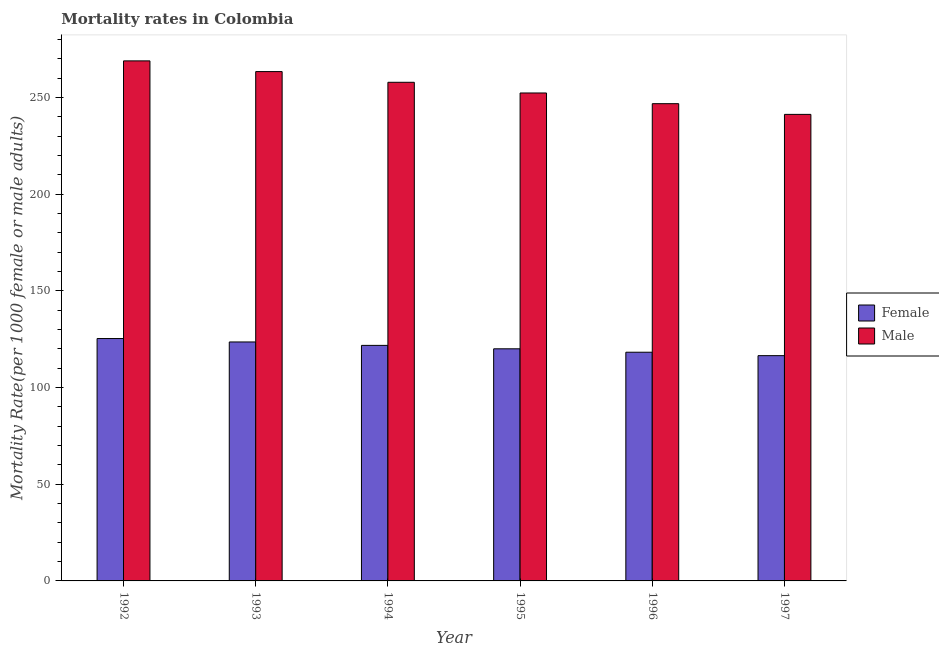How many different coloured bars are there?
Offer a terse response. 2. How many groups of bars are there?
Offer a terse response. 6. How many bars are there on the 2nd tick from the left?
Your response must be concise. 2. How many bars are there on the 6th tick from the right?
Provide a short and direct response. 2. What is the male mortality rate in 1993?
Keep it short and to the point. 263.33. Across all years, what is the maximum female mortality rate?
Your answer should be very brief. 125.31. Across all years, what is the minimum female mortality rate?
Your response must be concise. 116.47. In which year was the male mortality rate maximum?
Your answer should be very brief. 1992. In which year was the female mortality rate minimum?
Your response must be concise. 1997. What is the total female mortality rate in the graph?
Give a very brief answer. 725.33. What is the difference between the male mortality rate in 1992 and that in 1997?
Make the answer very short. 27.66. What is the difference between the female mortality rate in 1992 and the male mortality rate in 1996?
Provide a short and direct response. 7.08. What is the average female mortality rate per year?
Ensure brevity in your answer.  120.89. In the year 1992, what is the difference between the female mortality rate and male mortality rate?
Your answer should be compact. 0. In how many years, is the male mortality rate greater than 110?
Ensure brevity in your answer.  6. What is the ratio of the female mortality rate in 1993 to that in 1994?
Ensure brevity in your answer.  1.01. Is the male mortality rate in 1992 less than that in 1993?
Ensure brevity in your answer.  No. Is the difference between the male mortality rate in 1994 and 1996 greater than the difference between the female mortality rate in 1994 and 1996?
Keep it short and to the point. No. What is the difference between the highest and the second highest male mortality rate?
Make the answer very short. 5.53. What is the difference between the highest and the lowest female mortality rate?
Keep it short and to the point. 8.84. In how many years, is the male mortality rate greater than the average male mortality rate taken over all years?
Make the answer very short. 3. Is the sum of the female mortality rate in 1993 and 1996 greater than the maximum male mortality rate across all years?
Offer a terse response. Yes. What does the 1st bar from the left in 1992 represents?
Make the answer very short. Female. What does the 1st bar from the right in 1995 represents?
Ensure brevity in your answer.  Male. How many bars are there?
Your answer should be compact. 12. How many years are there in the graph?
Your answer should be compact. 6. Are the values on the major ticks of Y-axis written in scientific E-notation?
Keep it short and to the point. No. Where does the legend appear in the graph?
Ensure brevity in your answer.  Center right. How many legend labels are there?
Make the answer very short. 2. How are the legend labels stacked?
Keep it short and to the point. Vertical. What is the title of the graph?
Your answer should be compact. Mortality rates in Colombia. What is the label or title of the X-axis?
Offer a terse response. Year. What is the label or title of the Y-axis?
Provide a short and direct response. Mortality Rate(per 1000 female or male adults). What is the Mortality Rate(per 1000 female or male adults) of Female in 1992?
Offer a very short reply. 125.31. What is the Mortality Rate(per 1000 female or male adults) in Male in 1992?
Offer a very short reply. 268.86. What is the Mortality Rate(per 1000 female or male adults) of Female in 1993?
Offer a very short reply. 123.54. What is the Mortality Rate(per 1000 female or male adults) of Male in 1993?
Your response must be concise. 263.33. What is the Mortality Rate(per 1000 female or male adults) in Female in 1994?
Keep it short and to the point. 121.77. What is the Mortality Rate(per 1000 female or male adults) of Male in 1994?
Your response must be concise. 257.79. What is the Mortality Rate(per 1000 female or male adults) of Female in 1995?
Your answer should be very brief. 120. What is the Mortality Rate(per 1000 female or male adults) of Male in 1995?
Provide a short and direct response. 252.26. What is the Mortality Rate(per 1000 female or male adults) in Female in 1996?
Provide a short and direct response. 118.23. What is the Mortality Rate(per 1000 female or male adults) of Male in 1996?
Your response must be concise. 246.73. What is the Mortality Rate(per 1000 female or male adults) in Female in 1997?
Offer a very short reply. 116.47. What is the Mortality Rate(per 1000 female or male adults) in Male in 1997?
Keep it short and to the point. 241.19. Across all years, what is the maximum Mortality Rate(per 1000 female or male adults) in Female?
Your response must be concise. 125.31. Across all years, what is the maximum Mortality Rate(per 1000 female or male adults) in Male?
Ensure brevity in your answer.  268.86. Across all years, what is the minimum Mortality Rate(per 1000 female or male adults) of Female?
Provide a succinct answer. 116.47. Across all years, what is the minimum Mortality Rate(per 1000 female or male adults) of Male?
Your answer should be very brief. 241.19. What is the total Mortality Rate(per 1000 female or male adults) of Female in the graph?
Give a very brief answer. 725.33. What is the total Mortality Rate(per 1000 female or male adults) in Male in the graph?
Your answer should be compact. 1530.16. What is the difference between the Mortality Rate(per 1000 female or male adults) of Female in 1992 and that in 1993?
Offer a terse response. 1.77. What is the difference between the Mortality Rate(per 1000 female or male adults) in Male in 1992 and that in 1993?
Your answer should be very brief. 5.53. What is the difference between the Mortality Rate(per 1000 female or male adults) in Female in 1992 and that in 1994?
Ensure brevity in your answer.  3.54. What is the difference between the Mortality Rate(per 1000 female or male adults) in Male in 1992 and that in 1994?
Give a very brief answer. 11.07. What is the difference between the Mortality Rate(per 1000 female or male adults) in Female in 1992 and that in 1995?
Your answer should be very brief. 5.31. What is the difference between the Mortality Rate(per 1000 female or male adults) of Male in 1992 and that in 1995?
Keep it short and to the point. 16.6. What is the difference between the Mortality Rate(per 1000 female or male adults) of Female in 1992 and that in 1996?
Offer a terse response. 7.08. What is the difference between the Mortality Rate(per 1000 female or male adults) in Male in 1992 and that in 1996?
Give a very brief answer. 22.13. What is the difference between the Mortality Rate(per 1000 female or male adults) of Female in 1992 and that in 1997?
Provide a succinct answer. 8.85. What is the difference between the Mortality Rate(per 1000 female or male adults) in Male in 1992 and that in 1997?
Your answer should be very brief. 27.66. What is the difference between the Mortality Rate(per 1000 female or male adults) of Female in 1993 and that in 1994?
Your answer should be compact. 1.77. What is the difference between the Mortality Rate(per 1000 female or male adults) in Male in 1993 and that in 1994?
Your response must be concise. 5.53. What is the difference between the Mortality Rate(per 1000 female or male adults) of Female in 1993 and that in 1995?
Your response must be concise. 3.54. What is the difference between the Mortality Rate(per 1000 female or male adults) of Male in 1993 and that in 1995?
Give a very brief answer. 11.06. What is the difference between the Mortality Rate(per 1000 female or male adults) in Female in 1993 and that in 1996?
Your answer should be very brief. 5.31. What is the difference between the Mortality Rate(per 1000 female or male adults) of Male in 1993 and that in 1996?
Give a very brief answer. 16.6. What is the difference between the Mortality Rate(per 1000 female or male adults) of Female in 1993 and that in 1997?
Give a very brief answer. 7.08. What is the difference between the Mortality Rate(per 1000 female or male adults) in Male in 1993 and that in 1997?
Provide a short and direct response. 22.13. What is the difference between the Mortality Rate(per 1000 female or male adults) in Female in 1994 and that in 1995?
Ensure brevity in your answer.  1.77. What is the difference between the Mortality Rate(per 1000 female or male adults) of Male in 1994 and that in 1995?
Your answer should be very brief. 5.53. What is the difference between the Mortality Rate(per 1000 female or male adults) of Female in 1994 and that in 1996?
Make the answer very short. 3.54. What is the difference between the Mortality Rate(per 1000 female or male adults) of Male in 1994 and that in 1996?
Your response must be concise. 11.06. What is the difference between the Mortality Rate(per 1000 female or male adults) of Female in 1994 and that in 1997?
Your answer should be very brief. 5.31. What is the difference between the Mortality Rate(per 1000 female or male adults) of Male in 1994 and that in 1997?
Ensure brevity in your answer.  16.6. What is the difference between the Mortality Rate(per 1000 female or male adults) in Female in 1995 and that in 1996?
Provide a short and direct response. 1.77. What is the difference between the Mortality Rate(per 1000 female or male adults) in Male in 1995 and that in 1996?
Offer a terse response. 5.53. What is the difference between the Mortality Rate(per 1000 female or male adults) of Female in 1995 and that in 1997?
Your response must be concise. 3.54. What is the difference between the Mortality Rate(per 1000 female or male adults) in Male in 1995 and that in 1997?
Keep it short and to the point. 11.07. What is the difference between the Mortality Rate(per 1000 female or male adults) of Female in 1996 and that in 1997?
Your response must be concise. 1.77. What is the difference between the Mortality Rate(per 1000 female or male adults) in Male in 1996 and that in 1997?
Provide a short and direct response. 5.53. What is the difference between the Mortality Rate(per 1000 female or male adults) of Female in 1992 and the Mortality Rate(per 1000 female or male adults) of Male in 1993?
Ensure brevity in your answer.  -138.02. What is the difference between the Mortality Rate(per 1000 female or male adults) of Female in 1992 and the Mortality Rate(per 1000 female or male adults) of Male in 1994?
Keep it short and to the point. -132.48. What is the difference between the Mortality Rate(per 1000 female or male adults) in Female in 1992 and the Mortality Rate(per 1000 female or male adults) in Male in 1995?
Provide a short and direct response. -126.95. What is the difference between the Mortality Rate(per 1000 female or male adults) in Female in 1992 and the Mortality Rate(per 1000 female or male adults) in Male in 1996?
Make the answer very short. -121.42. What is the difference between the Mortality Rate(per 1000 female or male adults) of Female in 1992 and the Mortality Rate(per 1000 female or male adults) of Male in 1997?
Offer a very short reply. -115.89. What is the difference between the Mortality Rate(per 1000 female or male adults) of Female in 1993 and the Mortality Rate(per 1000 female or male adults) of Male in 1994?
Ensure brevity in your answer.  -134.25. What is the difference between the Mortality Rate(per 1000 female or male adults) of Female in 1993 and the Mortality Rate(per 1000 female or male adults) of Male in 1995?
Ensure brevity in your answer.  -128.72. What is the difference between the Mortality Rate(per 1000 female or male adults) in Female in 1993 and the Mortality Rate(per 1000 female or male adults) in Male in 1996?
Offer a terse response. -123.19. What is the difference between the Mortality Rate(per 1000 female or male adults) of Female in 1993 and the Mortality Rate(per 1000 female or male adults) of Male in 1997?
Ensure brevity in your answer.  -117.65. What is the difference between the Mortality Rate(per 1000 female or male adults) of Female in 1994 and the Mortality Rate(per 1000 female or male adults) of Male in 1995?
Your answer should be compact. -130.49. What is the difference between the Mortality Rate(per 1000 female or male adults) in Female in 1994 and the Mortality Rate(per 1000 female or male adults) in Male in 1996?
Your answer should be compact. -124.96. What is the difference between the Mortality Rate(per 1000 female or male adults) in Female in 1994 and the Mortality Rate(per 1000 female or male adults) in Male in 1997?
Ensure brevity in your answer.  -119.42. What is the difference between the Mortality Rate(per 1000 female or male adults) of Female in 1995 and the Mortality Rate(per 1000 female or male adults) of Male in 1996?
Your answer should be very brief. -126.72. What is the difference between the Mortality Rate(per 1000 female or male adults) in Female in 1995 and the Mortality Rate(per 1000 female or male adults) in Male in 1997?
Your answer should be compact. -121.19. What is the difference between the Mortality Rate(per 1000 female or male adults) in Female in 1996 and the Mortality Rate(per 1000 female or male adults) in Male in 1997?
Give a very brief answer. -122.96. What is the average Mortality Rate(per 1000 female or male adults) of Female per year?
Your answer should be very brief. 120.89. What is the average Mortality Rate(per 1000 female or male adults) in Male per year?
Ensure brevity in your answer.  255.03. In the year 1992, what is the difference between the Mortality Rate(per 1000 female or male adults) of Female and Mortality Rate(per 1000 female or male adults) of Male?
Offer a terse response. -143.55. In the year 1993, what is the difference between the Mortality Rate(per 1000 female or male adults) in Female and Mortality Rate(per 1000 female or male adults) in Male?
Your answer should be compact. -139.78. In the year 1994, what is the difference between the Mortality Rate(per 1000 female or male adults) in Female and Mortality Rate(per 1000 female or male adults) in Male?
Provide a succinct answer. -136.02. In the year 1995, what is the difference between the Mortality Rate(per 1000 female or male adults) in Female and Mortality Rate(per 1000 female or male adults) in Male?
Keep it short and to the point. -132.26. In the year 1996, what is the difference between the Mortality Rate(per 1000 female or male adults) in Female and Mortality Rate(per 1000 female or male adults) in Male?
Offer a very short reply. -128.49. In the year 1997, what is the difference between the Mortality Rate(per 1000 female or male adults) in Female and Mortality Rate(per 1000 female or male adults) in Male?
Provide a succinct answer. -124.73. What is the ratio of the Mortality Rate(per 1000 female or male adults) in Female in 1992 to that in 1993?
Offer a very short reply. 1.01. What is the ratio of the Mortality Rate(per 1000 female or male adults) of Female in 1992 to that in 1994?
Offer a very short reply. 1.03. What is the ratio of the Mortality Rate(per 1000 female or male adults) of Male in 1992 to that in 1994?
Make the answer very short. 1.04. What is the ratio of the Mortality Rate(per 1000 female or male adults) in Female in 1992 to that in 1995?
Make the answer very short. 1.04. What is the ratio of the Mortality Rate(per 1000 female or male adults) of Male in 1992 to that in 1995?
Your response must be concise. 1.07. What is the ratio of the Mortality Rate(per 1000 female or male adults) of Female in 1992 to that in 1996?
Your response must be concise. 1.06. What is the ratio of the Mortality Rate(per 1000 female or male adults) of Male in 1992 to that in 1996?
Ensure brevity in your answer.  1.09. What is the ratio of the Mortality Rate(per 1000 female or male adults) of Female in 1992 to that in 1997?
Make the answer very short. 1.08. What is the ratio of the Mortality Rate(per 1000 female or male adults) in Male in 1992 to that in 1997?
Your answer should be compact. 1.11. What is the ratio of the Mortality Rate(per 1000 female or male adults) in Female in 1993 to that in 1994?
Give a very brief answer. 1.01. What is the ratio of the Mortality Rate(per 1000 female or male adults) in Male in 1993 to that in 1994?
Give a very brief answer. 1.02. What is the ratio of the Mortality Rate(per 1000 female or male adults) in Female in 1993 to that in 1995?
Ensure brevity in your answer.  1.03. What is the ratio of the Mortality Rate(per 1000 female or male adults) in Male in 1993 to that in 1995?
Offer a very short reply. 1.04. What is the ratio of the Mortality Rate(per 1000 female or male adults) of Female in 1993 to that in 1996?
Offer a terse response. 1.04. What is the ratio of the Mortality Rate(per 1000 female or male adults) in Male in 1993 to that in 1996?
Provide a succinct answer. 1.07. What is the ratio of the Mortality Rate(per 1000 female or male adults) in Female in 1993 to that in 1997?
Keep it short and to the point. 1.06. What is the ratio of the Mortality Rate(per 1000 female or male adults) in Male in 1993 to that in 1997?
Provide a succinct answer. 1.09. What is the ratio of the Mortality Rate(per 1000 female or male adults) in Female in 1994 to that in 1995?
Ensure brevity in your answer.  1.01. What is the ratio of the Mortality Rate(per 1000 female or male adults) of Male in 1994 to that in 1995?
Provide a short and direct response. 1.02. What is the ratio of the Mortality Rate(per 1000 female or male adults) of Female in 1994 to that in 1996?
Give a very brief answer. 1.03. What is the ratio of the Mortality Rate(per 1000 female or male adults) of Male in 1994 to that in 1996?
Make the answer very short. 1.04. What is the ratio of the Mortality Rate(per 1000 female or male adults) of Female in 1994 to that in 1997?
Provide a succinct answer. 1.05. What is the ratio of the Mortality Rate(per 1000 female or male adults) in Male in 1994 to that in 1997?
Ensure brevity in your answer.  1.07. What is the ratio of the Mortality Rate(per 1000 female or male adults) in Female in 1995 to that in 1996?
Ensure brevity in your answer.  1.01. What is the ratio of the Mortality Rate(per 1000 female or male adults) in Male in 1995 to that in 1996?
Make the answer very short. 1.02. What is the ratio of the Mortality Rate(per 1000 female or male adults) of Female in 1995 to that in 1997?
Offer a very short reply. 1.03. What is the ratio of the Mortality Rate(per 1000 female or male adults) in Male in 1995 to that in 1997?
Ensure brevity in your answer.  1.05. What is the ratio of the Mortality Rate(per 1000 female or male adults) in Female in 1996 to that in 1997?
Make the answer very short. 1.02. What is the ratio of the Mortality Rate(per 1000 female or male adults) in Male in 1996 to that in 1997?
Keep it short and to the point. 1.02. What is the difference between the highest and the second highest Mortality Rate(per 1000 female or male adults) of Female?
Your response must be concise. 1.77. What is the difference between the highest and the second highest Mortality Rate(per 1000 female or male adults) of Male?
Ensure brevity in your answer.  5.53. What is the difference between the highest and the lowest Mortality Rate(per 1000 female or male adults) of Female?
Make the answer very short. 8.85. What is the difference between the highest and the lowest Mortality Rate(per 1000 female or male adults) of Male?
Keep it short and to the point. 27.66. 